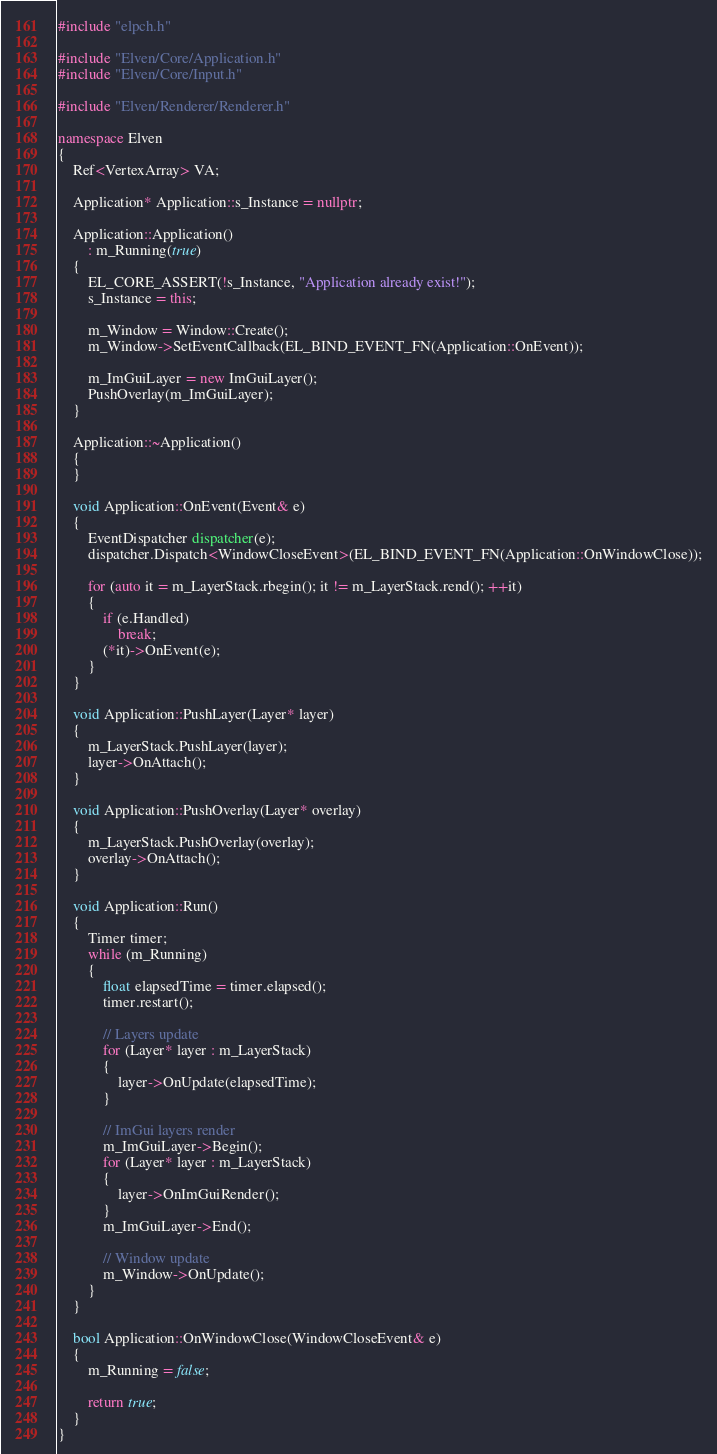Convert code to text. <code><loc_0><loc_0><loc_500><loc_500><_C++_>#include "elpch.h"

#include "Elven/Core/Application.h"
#include "Elven/Core/Input.h"

#include "Elven/Renderer/Renderer.h"

namespace Elven
{
    Ref<VertexArray> VA;

    Application* Application::s_Instance = nullptr;

    Application::Application()
        : m_Running(true)
    {
        EL_CORE_ASSERT(!s_Instance, "Application already exist!");
        s_Instance = this;

        m_Window = Window::Create();
        m_Window->SetEventCallback(EL_BIND_EVENT_FN(Application::OnEvent));

        m_ImGuiLayer = new ImGuiLayer();
        PushOverlay(m_ImGuiLayer);
    }

    Application::~Application()
    {
    }

    void Application::OnEvent(Event& e)
    {
        EventDispatcher dispatcher(e);
        dispatcher.Dispatch<WindowCloseEvent>(EL_BIND_EVENT_FN(Application::OnWindowClose));

        for (auto it = m_LayerStack.rbegin(); it != m_LayerStack.rend(); ++it)
        {
            if (e.Handled)
                break;
            (*it)->OnEvent(e);
        }
    }

    void Application::PushLayer(Layer* layer)
    {
        m_LayerStack.PushLayer(layer);
        layer->OnAttach();
    }

    void Application::PushOverlay(Layer* overlay)
    {
        m_LayerStack.PushOverlay(overlay);
        overlay->OnAttach();
    }

    void Application::Run()
    {
        Timer timer;
        while (m_Running)
        {
            float elapsedTime = timer.elapsed();
            timer.restart();

            // Layers update
            for (Layer* layer : m_LayerStack)
            {
                layer->OnUpdate(elapsedTime);
            }

            // ImGui layers render
            m_ImGuiLayer->Begin();
            for (Layer* layer : m_LayerStack)
            {
                layer->OnImGuiRender();
            }
            m_ImGuiLayer->End();

            // Window update
            m_Window->OnUpdate();
        }
    }

    bool Application::OnWindowClose(WindowCloseEvent& e)
    {
        m_Running = false;

        return true;
    }
}</code> 